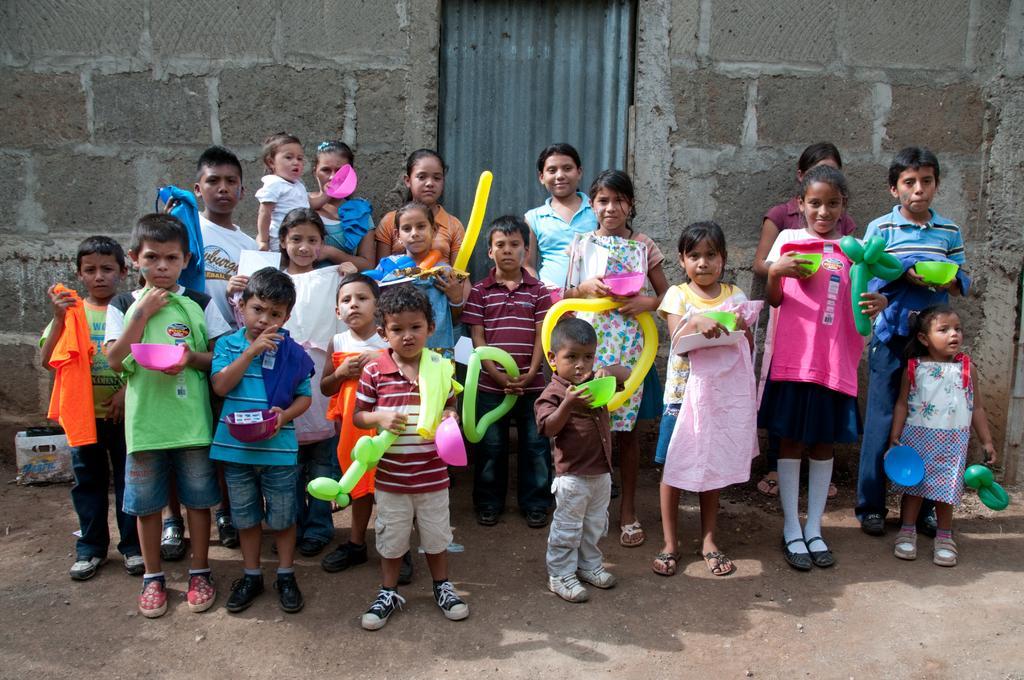In one or two sentences, can you explain what this image depicts? In this image we can see a group of people standing and holding some objects in their hands. We can see the wall in the image. There is an object placed on the ground at the left side of the image. 